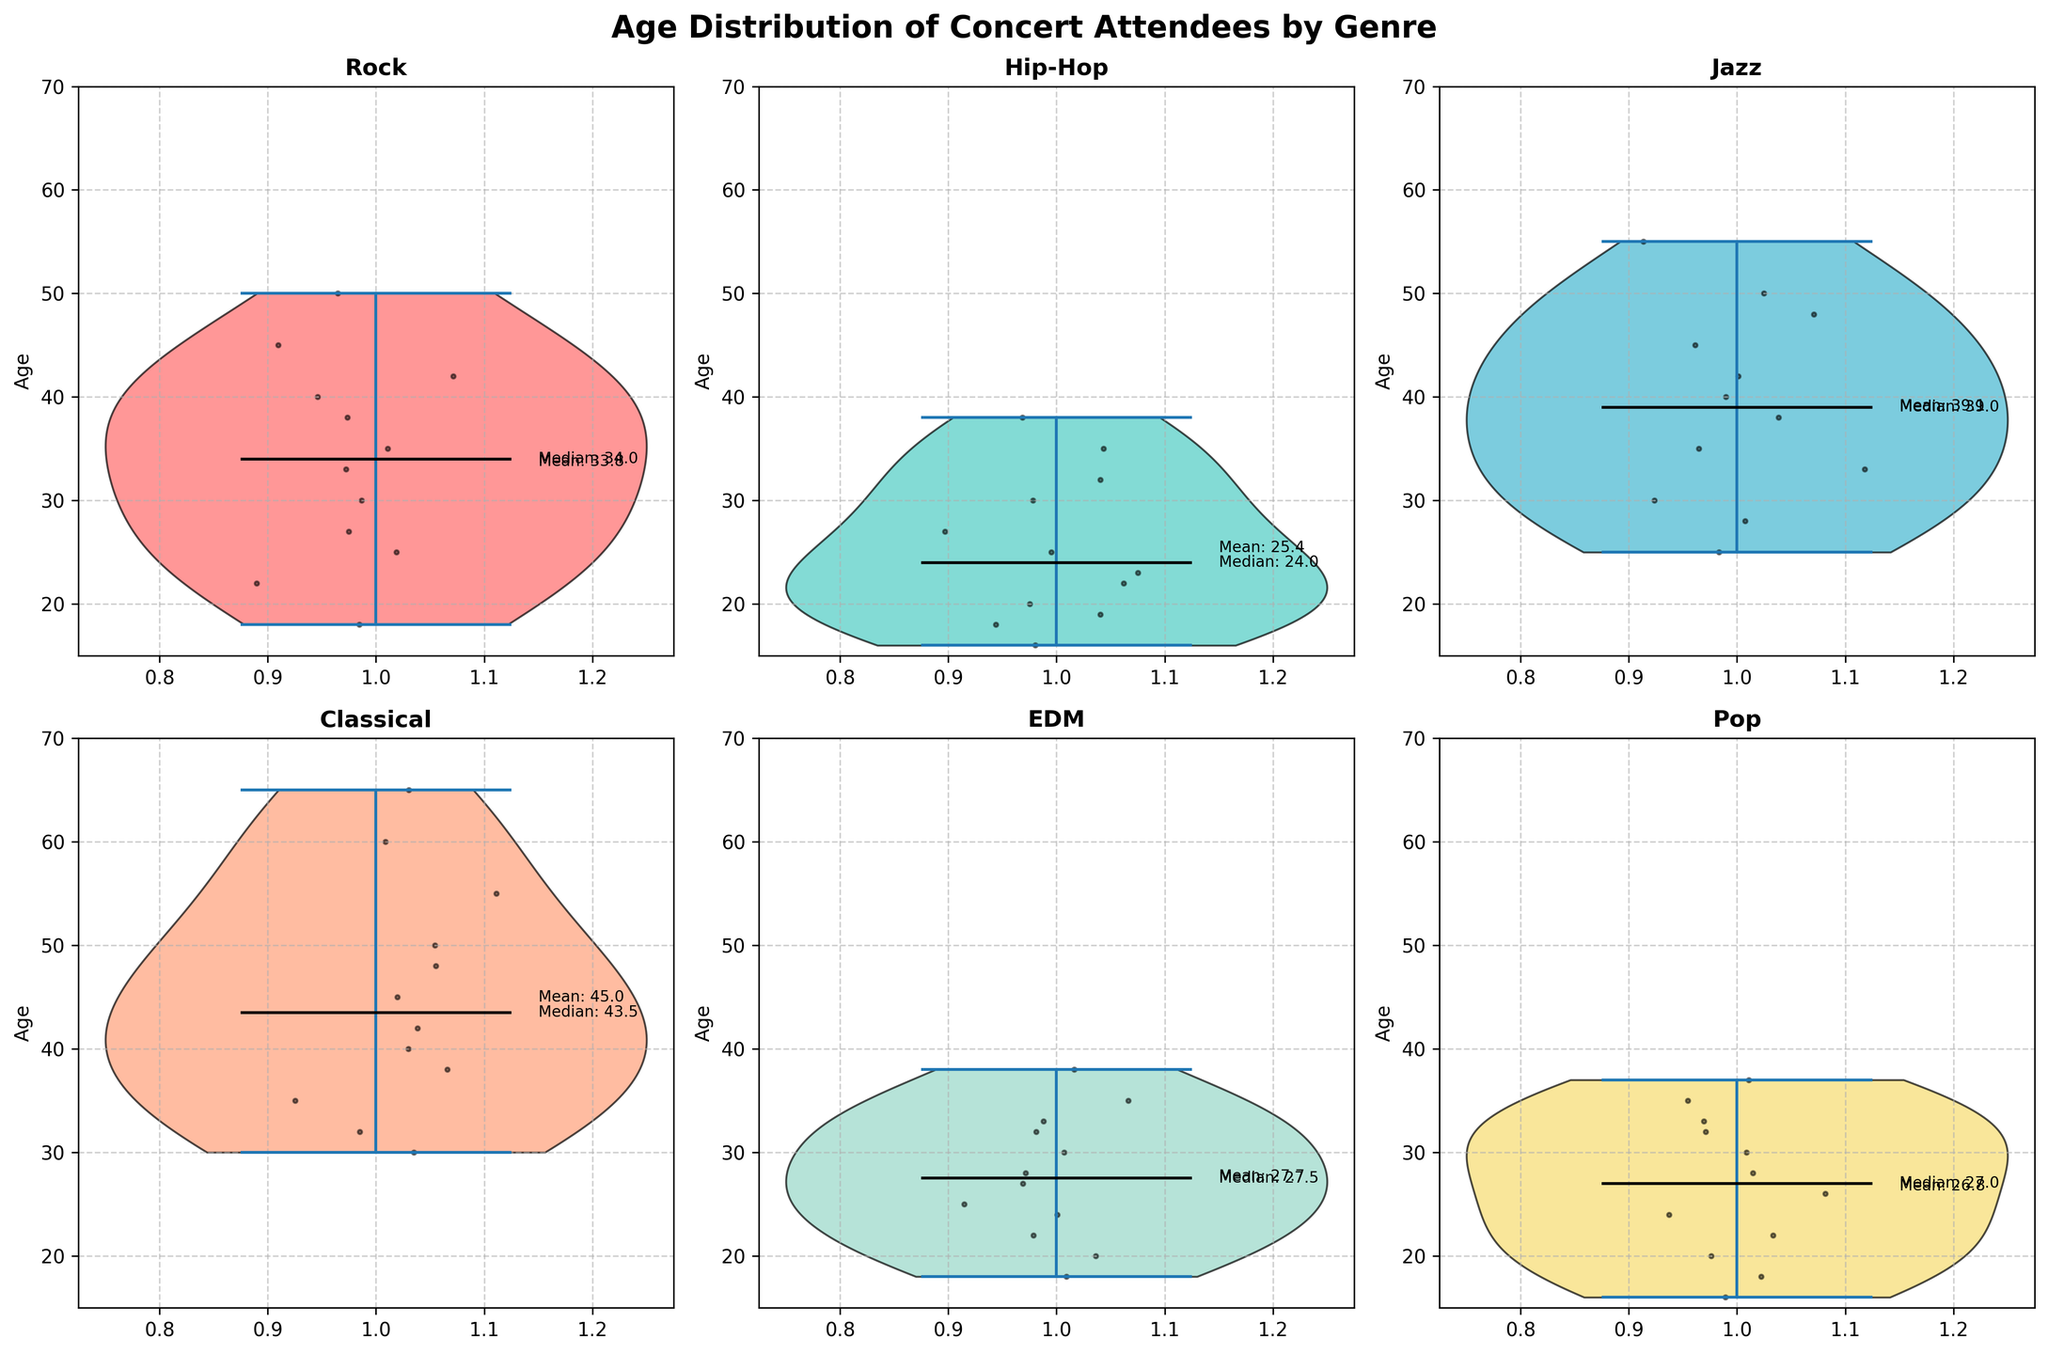What's the median age of Rock concert attendees? To find the median age, locate the middle value in the sorted list of ages for Rock concert attendees. In this case, the data shows the median is marked by a black line inside the Rock violin plot.
Answer: 35 Which genre has the youngest median age for attendees? By checking the violin plots for each of the genres, the Hip-Hop genre visibly has the lowest position for the black median line, indicating the youngest median age.
Answer: Hip-Hop What's the mean age of Classical concert attendees? The mean age is annotated next to the Classical violin plot. Locate the text indicating the mean value; it's provided as a numerical annotation within the figure.
Answer: 45.1 How does the age spread of Jazz concert attendees compare to Rock concert attendees? Examine the range and density of the age distribution for both Jazz and Rock. The spread is wider in Jazz, covering ages from about 25 to 55, whereas Rock spans from 18 to 50. This indicates Jazz has a more varied age distribution compared to Rock.
Answer: Jazz has a wider spread Which genre has the most overlap with Rock in terms of age distribution? Compare the violin plots to see which genre closely matches the height and density of Rock. Both EDM and Pop have similar age ranges, but Pop appears to have a closer distribution with ages between 16 and 37, overlapping with Rock's 18 to 50 range.
Answer: Pop Is the age distribution more symmetrical for EDM or Classical music? To determine the symmetry of the distribution, examine the shape of each violin plot. The EDM plot is more symmetrical, as it is evenly distributed around its central range, whereas Classical shows a skew toward the older ages.
Answer: EDM What's the age range for Hip-Hop concert attendees? Check the vertical extent of the Hip-Hop violin plot. It starts at 16 and goes up to 38, indicating the age range.
Answer: 16 to 38 Which genre has the oldest mean age for concert attendees? Locate the annotated mean values in each subplot. Classical music has the annotated mean being the highest among the genres.
Answer: Classical Are there more young attendees (under 30) at Rock concerts or Pop concerts? By comparing the density of the younger segment (under 30) in both violin plots, Pop shows a denser and more concentrated distribution under 30, indicating more young attendees at Pop concerts.
Answer: Pop 